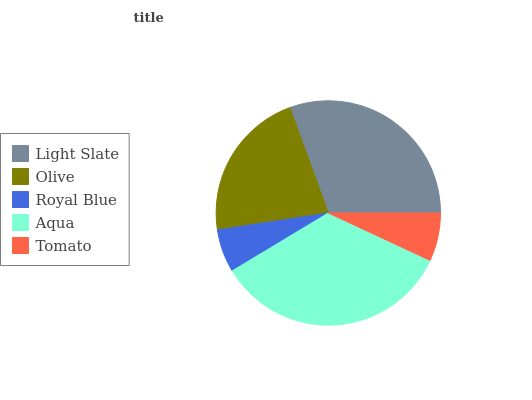Is Royal Blue the minimum?
Answer yes or no. Yes. Is Aqua the maximum?
Answer yes or no. Yes. Is Olive the minimum?
Answer yes or no. No. Is Olive the maximum?
Answer yes or no. No. Is Light Slate greater than Olive?
Answer yes or no. Yes. Is Olive less than Light Slate?
Answer yes or no. Yes. Is Olive greater than Light Slate?
Answer yes or no. No. Is Light Slate less than Olive?
Answer yes or no. No. Is Olive the high median?
Answer yes or no. Yes. Is Olive the low median?
Answer yes or no. Yes. Is Tomato the high median?
Answer yes or no. No. Is Tomato the low median?
Answer yes or no. No. 